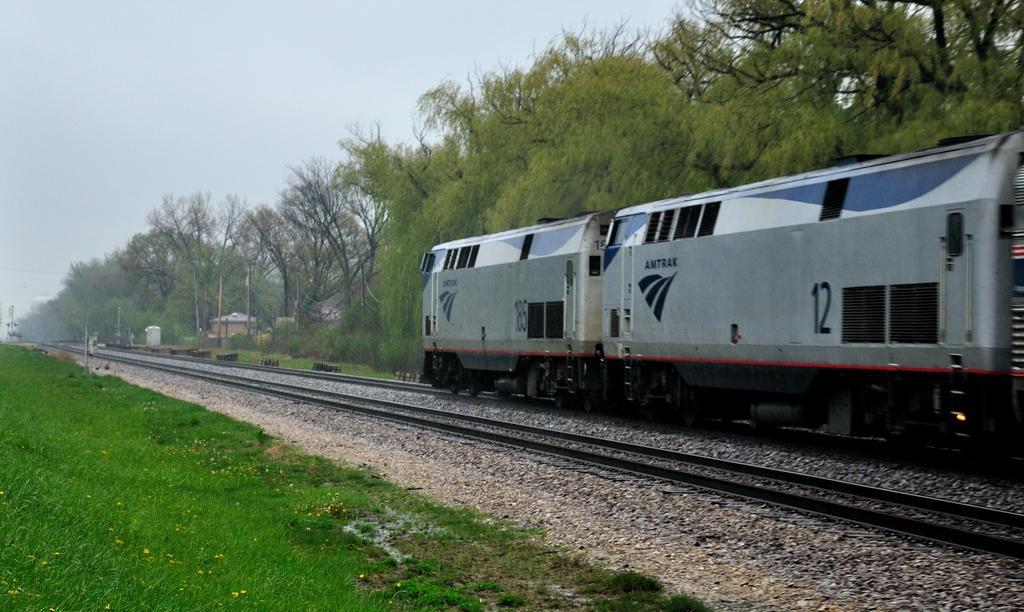Please provide a concise description of this image. In the image we can see a train on the train tracks. Here we can see grass, stones, trees and a sky. 